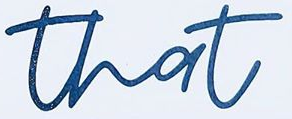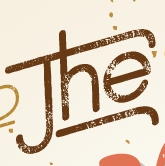Transcribe the words shown in these images in order, separated by a semicolon. that; The 